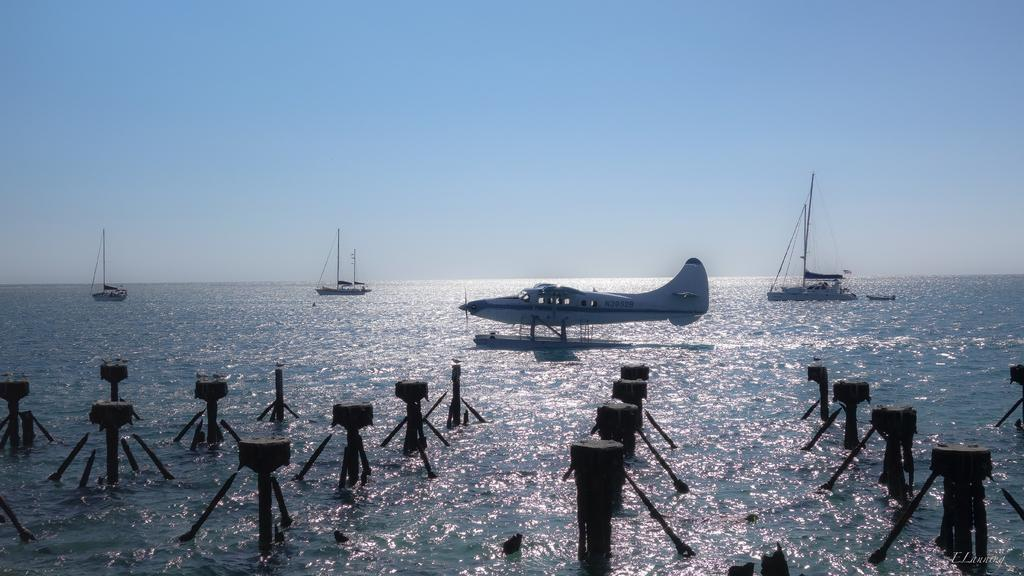What is located above the water in the image? There are boats and a plane above the water in the image. What is the color of the sky in the image? The sky is blue in color. What type of wool is being used to make the sails of the boats in the image? There is no wool or sails present in the image; the boats are above the water, but their construction materials are not visible. 